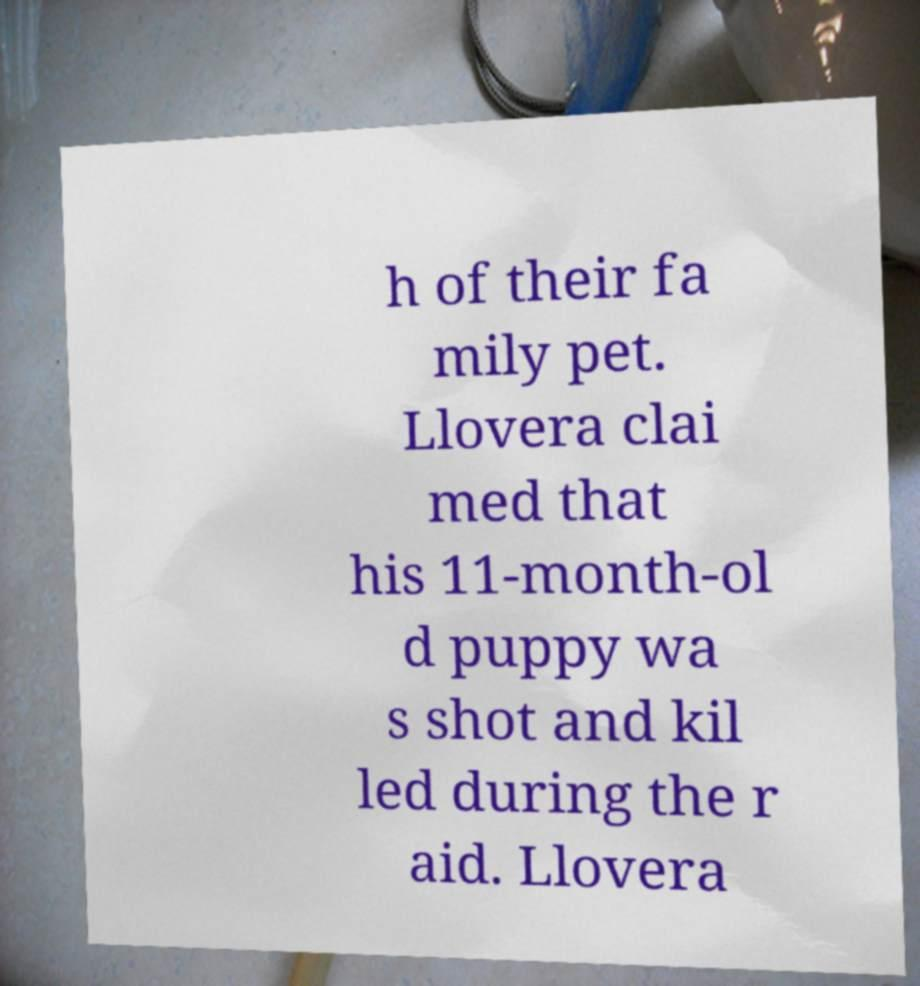Could you extract and type out the text from this image? h of their fa mily pet. Llovera clai med that his 11-month-ol d puppy wa s shot and kil led during the r aid. Llovera 